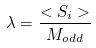Convert formula to latex. <formula><loc_0><loc_0><loc_500><loc_500>\lambda = \frac { < S _ { i } > } { M _ { o d d } }</formula> 